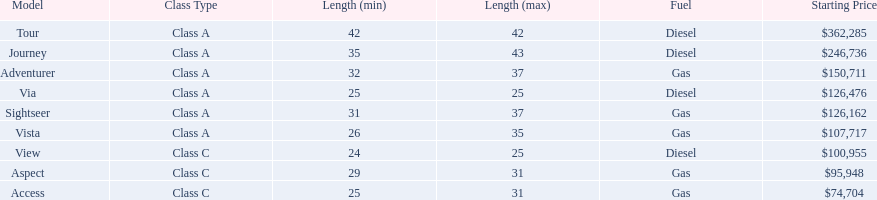What is the highest price of a winnebago model? $362,285. Give me the full table as a dictionary. {'header': ['Model', 'Class Type', 'Length (min)', 'Length (max)', 'Fuel', 'Starting Price'], 'rows': [['Tour', 'Class A', '42', '42', 'Diesel', '$362,285'], ['Journey', 'Class A', '35', '43', 'Diesel', '$246,736'], ['Adventurer', 'Class A', '32', '37', 'Gas', '$150,711'], ['Via', 'Class A', '25', '25', 'Diesel', '$126,476'], ['Sightseer', 'Class A', '31', '37', 'Gas', '$126,162'], ['Vista', 'Class A', '26', '35', 'Gas', '$107,717'], ['View', 'Class C', '24', '25', 'Diesel', '$100,955'], ['Aspect', 'Class C', '29', '31', 'Gas', '$95,948'], ['Access', 'Class C', '25', '31', 'Gas', '$74,704']]} What is the name of the vehicle with this price? Tour. 